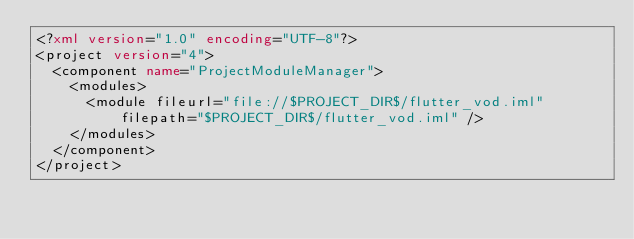<code> <loc_0><loc_0><loc_500><loc_500><_XML_><?xml version="1.0" encoding="UTF-8"?>
<project version="4">
  <component name="ProjectModuleManager">
    <modules>
      <module fileurl="file://$PROJECT_DIR$/flutter_vod.iml" filepath="$PROJECT_DIR$/flutter_vod.iml" />
    </modules>
  </component>
</project></code> 